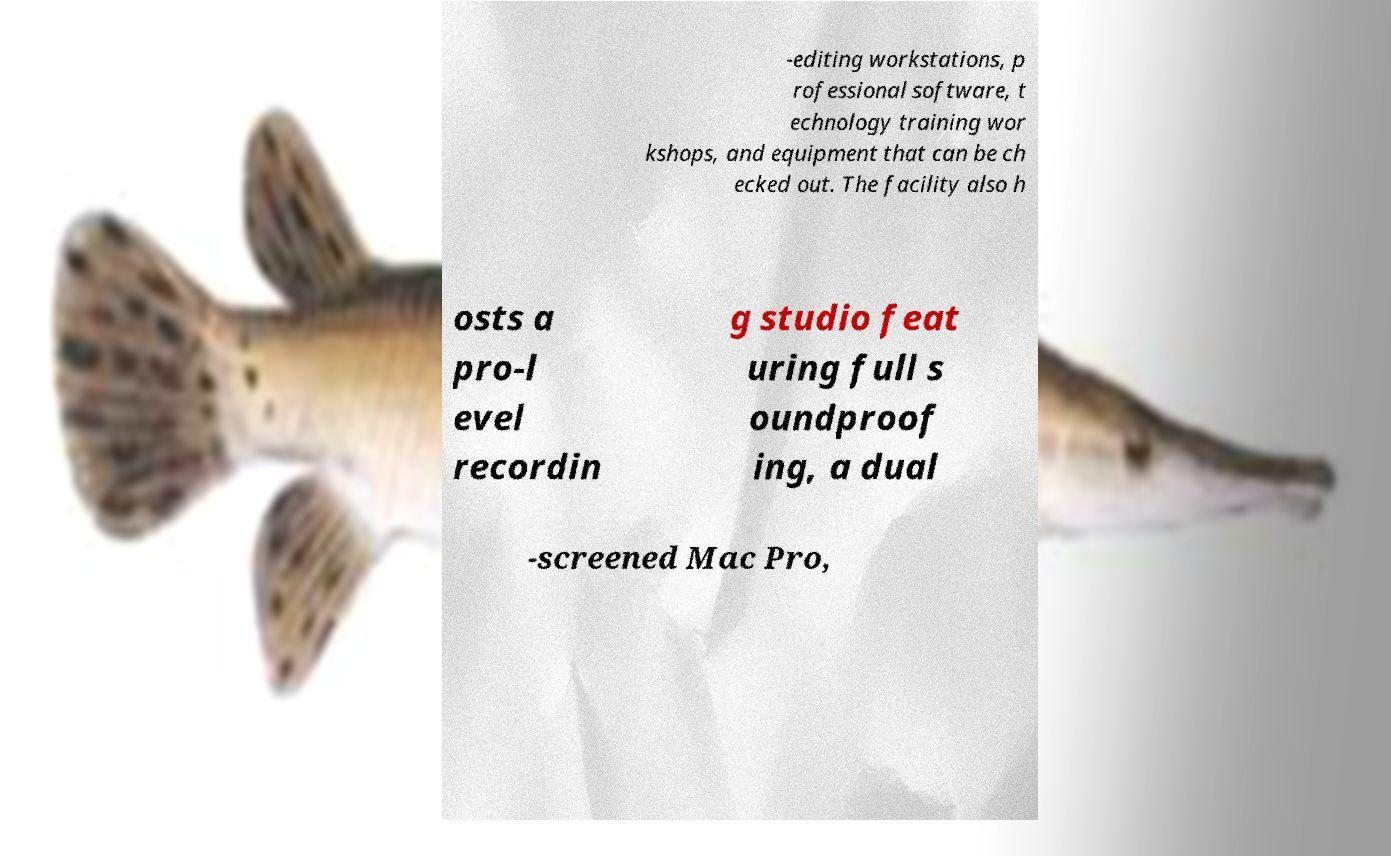Can you read and provide the text displayed in the image?This photo seems to have some interesting text. Can you extract and type it out for me? -editing workstations, p rofessional software, t echnology training wor kshops, and equipment that can be ch ecked out. The facility also h osts a pro-l evel recordin g studio feat uring full s oundproof ing, a dual -screened Mac Pro, 